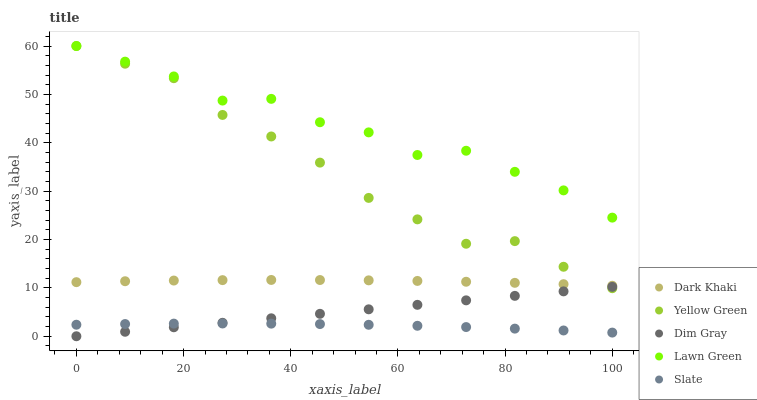Does Slate have the minimum area under the curve?
Answer yes or no. Yes. Does Lawn Green have the maximum area under the curve?
Answer yes or no. Yes. Does Lawn Green have the minimum area under the curve?
Answer yes or no. No. Does Slate have the maximum area under the curve?
Answer yes or no. No. Is Dim Gray the smoothest?
Answer yes or no. Yes. Is Lawn Green the roughest?
Answer yes or no. Yes. Is Slate the smoothest?
Answer yes or no. No. Is Slate the roughest?
Answer yes or no. No. Does Dim Gray have the lowest value?
Answer yes or no. Yes. Does Slate have the lowest value?
Answer yes or no. No. Does Yellow Green have the highest value?
Answer yes or no. Yes. Does Slate have the highest value?
Answer yes or no. No. Is Dim Gray less than Lawn Green?
Answer yes or no. Yes. Is Dark Khaki greater than Dim Gray?
Answer yes or no. Yes. Does Lawn Green intersect Yellow Green?
Answer yes or no. Yes. Is Lawn Green less than Yellow Green?
Answer yes or no. No. Is Lawn Green greater than Yellow Green?
Answer yes or no. No. Does Dim Gray intersect Lawn Green?
Answer yes or no. No. 